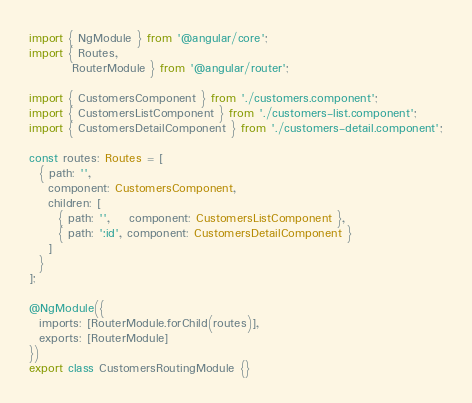<code> <loc_0><loc_0><loc_500><loc_500><_TypeScript_>import { NgModule } from '@angular/core';
import { Routes,
         RouterModule } from '@angular/router';

import { CustomersComponent } from './customers.component';
import { CustomersListComponent } from './customers-list.component';
import { CustomersDetailComponent } from './customers-detail.component';

const routes: Routes = [
  { path: '',
    component: CustomersComponent,
    children: [
      { path: '',    component: CustomersListComponent },
      { path: ':id', component: CustomersDetailComponent }
    ]
  }
];

@NgModule({
  imports: [RouterModule.forChild(routes)],
  exports: [RouterModule]
})
export class CustomersRoutingModule {}
</code> 